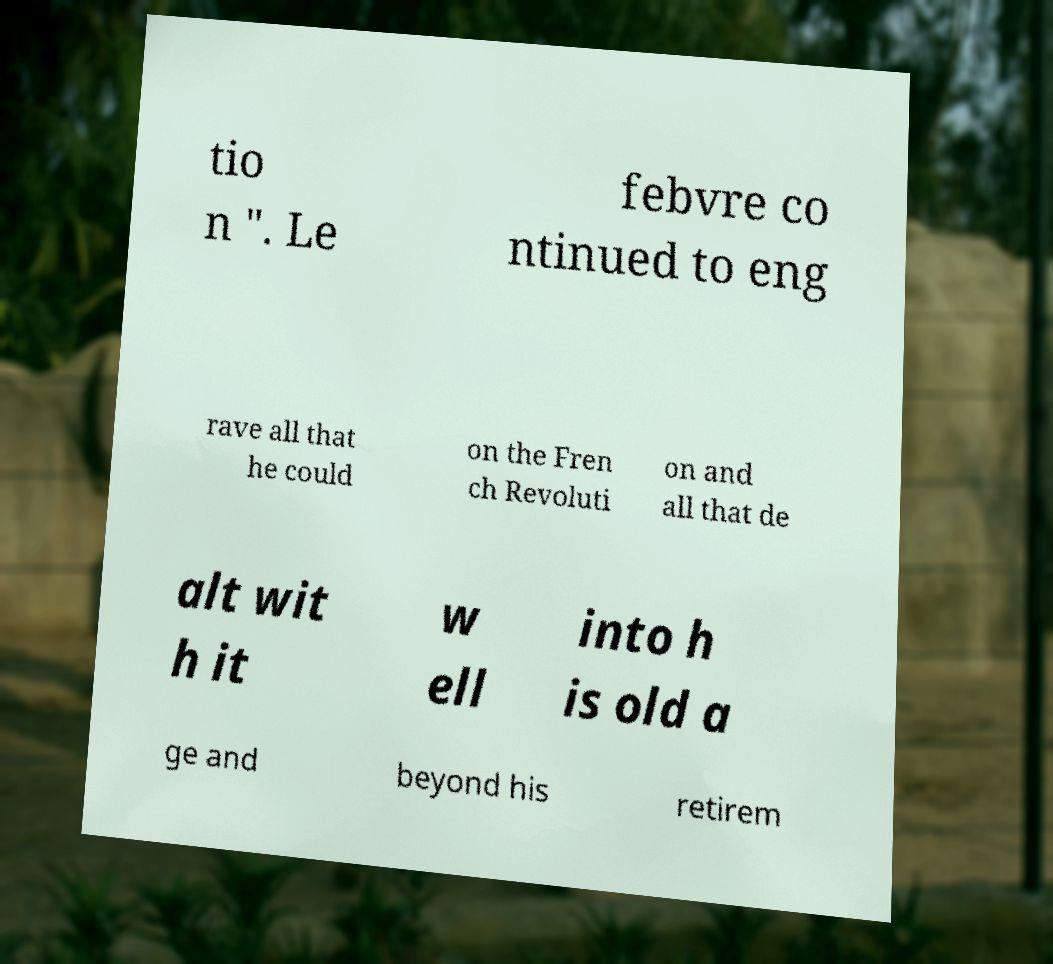For documentation purposes, I need the text within this image transcribed. Could you provide that? tio n ". Le febvre co ntinued to eng rave all that he could on the Fren ch Revoluti on and all that de alt wit h it w ell into h is old a ge and beyond his retirem 